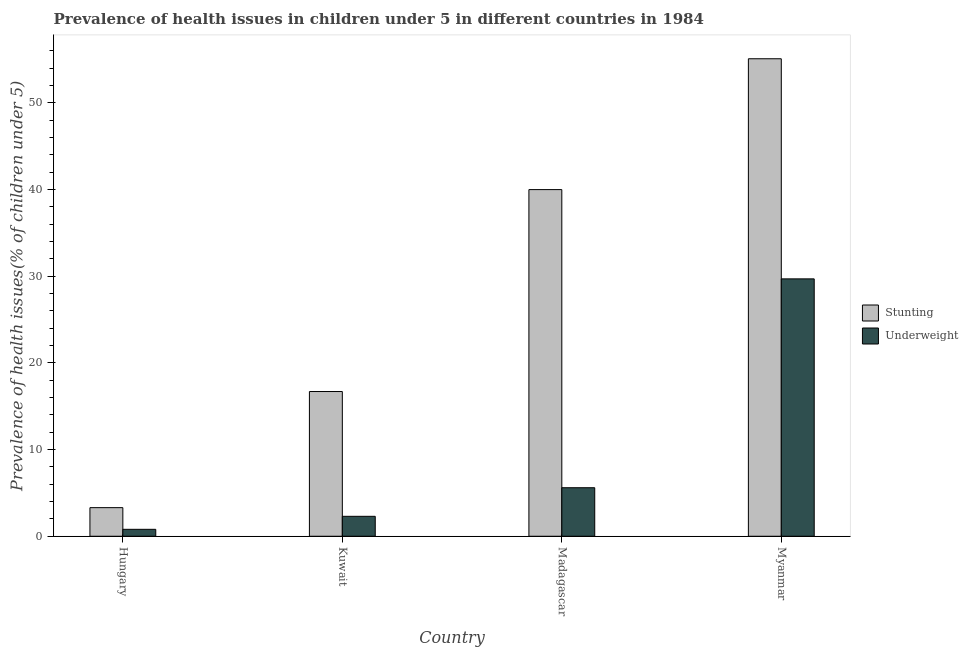How many different coloured bars are there?
Your answer should be compact. 2. How many groups of bars are there?
Offer a very short reply. 4. Are the number of bars on each tick of the X-axis equal?
Keep it short and to the point. Yes. How many bars are there on the 2nd tick from the left?
Provide a short and direct response. 2. What is the label of the 2nd group of bars from the left?
Your answer should be compact. Kuwait. What is the percentage of stunted children in Myanmar?
Your answer should be compact. 55.1. Across all countries, what is the maximum percentage of underweight children?
Provide a short and direct response. 29.7. Across all countries, what is the minimum percentage of underweight children?
Provide a succinct answer. 0.8. In which country was the percentage of stunted children maximum?
Provide a succinct answer. Myanmar. In which country was the percentage of stunted children minimum?
Offer a very short reply. Hungary. What is the total percentage of underweight children in the graph?
Your answer should be very brief. 38.4. What is the difference between the percentage of underweight children in Kuwait and that in Myanmar?
Provide a short and direct response. -27.4. What is the difference between the percentage of stunted children in Hungary and the percentage of underweight children in Myanmar?
Your answer should be compact. -26.4. What is the average percentage of underweight children per country?
Keep it short and to the point. 9.6. What is the difference between the percentage of underweight children and percentage of stunted children in Myanmar?
Make the answer very short. -25.4. In how many countries, is the percentage of underweight children greater than 10 %?
Ensure brevity in your answer.  1. What is the ratio of the percentage of stunted children in Madagascar to that in Myanmar?
Make the answer very short. 0.73. Is the percentage of underweight children in Hungary less than that in Kuwait?
Offer a terse response. Yes. Is the difference between the percentage of stunted children in Kuwait and Madagascar greater than the difference between the percentage of underweight children in Kuwait and Madagascar?
Offer a terse response. No. What is the difference between the highest and the second highest percentage of stunted children?
Give a very brief answer. 15.1. What is the difference between the highest and the lowest percentage of stunted children?
Your response must be concise. 51.8. What does the 1st bar from the left in Myanmar represents?
Provide a short and direct response. Stunting. What does the 2nd bar from the right in Myanmar represents?
Keep it short and to the point. Stunting. How many bars are there?
Provide a succinct answer. 8. Are all the bars in the graph horizontal?
Keep it short and to the point. No. Are the values on the major ticks of Y-axis written in scientific E-notation?
Offer a very short reply. No. Does the graph contain any zero values?
Make the answer very short. No. Where does the legend appear in the graph?
Make the answer very short. Center right. How many legend labels are there?
Offer a terse response. 2. What is the title of the graph?
Your answer should be compact. Prevalence of health issues in children under 5 in different countries in 1984. Does "Total Population" appear as one of the legend labels in the graph?
Give a very brief answer. No. What is the label or title of the Y-axis?
Offer a terse response. Prevalence of health issues(% of children under 5). What is the Prevalence of health issues(% of children under 5) of Stunting in Hungary?
Offer a very short reply. 3.3. What is the Prevalence of health issues(% of children under 5) of Underweight in Hungary?
Give a very brief answer. 0.8. What is the Prevalence of health issues(% of children under 5) of Stunting in Kuwait?
Make the answer very short. 16.7. What is the Prevalence of health issues(% of children under 5) in Underweight in Kuwait?
Offer a terse response. 2.3. What is the Prevalence of health issues(% of children under 5) in Underweight in Madagascar?
Give a very brief answer. 5.6. What is the Prevalence of health issues(% of children under 5) in Stunting in Myanmar?
Ensure brevity in your answer.  55.1. What is the Prevalence of health issues(% of children under 5) of Underweight in Myanmar?
Offer a terse response. 29.7. Across all countries, what is the maximum Prevalence of health issues(% of children under 5) in Stunting?
Keep it short and to the point. 55.1. Across all countries, what is the maximum Prevalence of health issues(% of children under 5) in Underweight?
Your answer should be very brief. 29.7. Across all countries, what is the minimum Prevalence of health issues(% of children under 5) of Stunting?
Offer a terse response. 3.3. Across all countries, what is the minimum Prevalence of health issues(% of children under 5) in Underweight?
Your answer should be very brief. 0.8. What is the total Prevalence of health issues(% of children under 5) in Stunting in the graph?
Make the answer very short. 115.1. What is the total Prevalence of health issues(% of children under 5) of Underweight in the graph?
Offer a terse response. 38.4. What is the difference between the Prevalence of health issues(% of children under 5) in Stunting in Hungary and that in Kuwait?
Your answer should be very brief. -13.4. What is the difference between the Prevalence of health issues(% of children under 5) of Stunting in Hungary and that in Madagascar?
Provide a succinct answer. -36.7. What is the difference between the Prevalence of health issues(% of children under 5) of Stunting in Hungary and that in Myanmar?
Your response must be concise. -51.8. What is the difference between the Prevalence of health issues(% of children under 5) in Underweight in Hungary and that in Myanmar?
Ensure brevity in your answer.  -28.9. What is the difference between the Prevalence of health issues(% of children under 5) of Stunting in Kuwait and that in Madagascar?
Make the answer very short. -23.3. What is the difference between the Prevalence of health issues(% of children under 5) in Underweight in Kuwait and that in Madagascar?
Your answer should be compact. -3.3. What is the difference between the Prevalence of health issues(% of children under 5) in Stunting in Kuwait and that in Myanmar?
Offer a very short reply. -38.4. What is the difference between the Prevalence of health issues(% of children under 5) in Underweight in Kuwait and that in Myanmar?
Make the answer very short. -27.4. What is the difference between the Prevalence of health issues(% of children under 5) in Stunting in Madagascar and that in Myanmar?
Offer a very short reply. -15.1. What is the difference between the Prevalence of health issues(% of children under 5) in Underweight in Madagascar and that in Myanmar?
Make the answer very short. -24.1. What is the difference between the Prevalence of health issues(% of children under 5) in Stunting in Hungary and the Prevalence of health issues(% of children under 5) in Underweight in Kuwait?
Your answer should be very brief. 1. What is the difference between the Prevalence of health issues(% of children under 5) in Stunting in Hungary and the Prevalence of health issues(% of children under 5) in Underweight in Myanmar?
Your answer should be compact. -26.4. What is the difference between the Prevalence of health issues(% of children under 5) in Stunting in Kuwait and the Prevalence of health issues(% of children under 5) in Underweight in Myanmar?
Offer a terse response. -13. What is the average Prevalence of health issues(% of children under 5) of Stunting per country?
Your answer should be very brief. 28.77. What is the average Prevalence of health issues(% of children under 5) of Underweight per country?
Provide a succinct answer. 9.6. What is the difference between the Prevalence of health issues(% of children under 5) of Stunting and Prevalence of health issues(% of children under 5) of Underweight in Hungary?
Your answer should be very brief. 2.5. What is the difference between the Prevalence of health issues(% of children under 5) of Stunting and Prevalence of health issues(% of children under 5) of Underweight in Madagascar?
Provide a succinct answer. 34.4. What is the difference between the Prevalence of health issues(% of children under 5) in Stunting and Prevalence of health issues(% of children under 5) in Underweight in Myanmar?
Give a very brief answer. 25.4. What is the ratio of the Prevalence of health issues(% of children under 5) in Stunting in Hungary to that in Kuwait?
Provide a short and direct response. 0.2. What is the ratio of the Prevalence of health issues(% of children under 5) in Underweight in Hungary to that in Kuwait?
Offer a very short reply. 0.35. What is the ratio of the Prevalence of health issues(% of children under 5) in Stunting in Hungary to that in Madagascar?
Provide a succinct answer. 0.08. What is the ratio of the Prevalence of health issues(% of children under 5) in Underweight in Hungary to that in Madagascar?
Your answer should be very brief. 0.14. What is the ratio of the Prevalence of health issues(% of children under 5) in Stunting in Hungary to that in Myanmar?
Provide a short and direct response. 0.06. What is the ratio of the Prevalence of health issues(% of children under 5) of Underweight in Hungary to that in Myanmar?
Give a very brief answer. 0.03. What is the ratio of the Prevalence of health issues(% of children under 5) in Stunting in Kuwait to that in Madagascar?
Your answer should be compact. 0.42. What is the ratio of the Prevalence of health issues(% of children under 5) of Underweight in Kuwait to that in Madagascar?
Make the answer very short. 0.41. What is the ratio of the Prevalence of health issues(% of children under 5) in Stunting in Kuwait to that in Myanmar?
Make the answer very short. 0.3. What is the ratio of the Prevalence of health issues(% of children under 5) of Underweight in Kuwait to that in Myanmar?
Your answer should be compact. 0.08. What is the ratio of the Prevalence of health issues(% of children under 5) in Stunting in Madagascar to that in Myanmar?
Your answer should be compact. 0.73. What is the ratio of the Prevalence of health issues(% of children under 5) in Underweight in Madagascar to that in Myanmar?
Make the answer very short. 0.19. What is the difference between the highest and the second highest Prevalence of health issues(% of children under 5) in Underweight?
Ensure brevity in your answer.  24.1. What is the difference between the highest and the lowest Prevalence of health issues(% of children under 5) of Stunting?
Ensure brevity in your answer.  51.8. What is the difference between the highest and the lowest Prevalence of health issues(% of children under 5) in Underweight?
Keep it short and to the point. 28.9. 